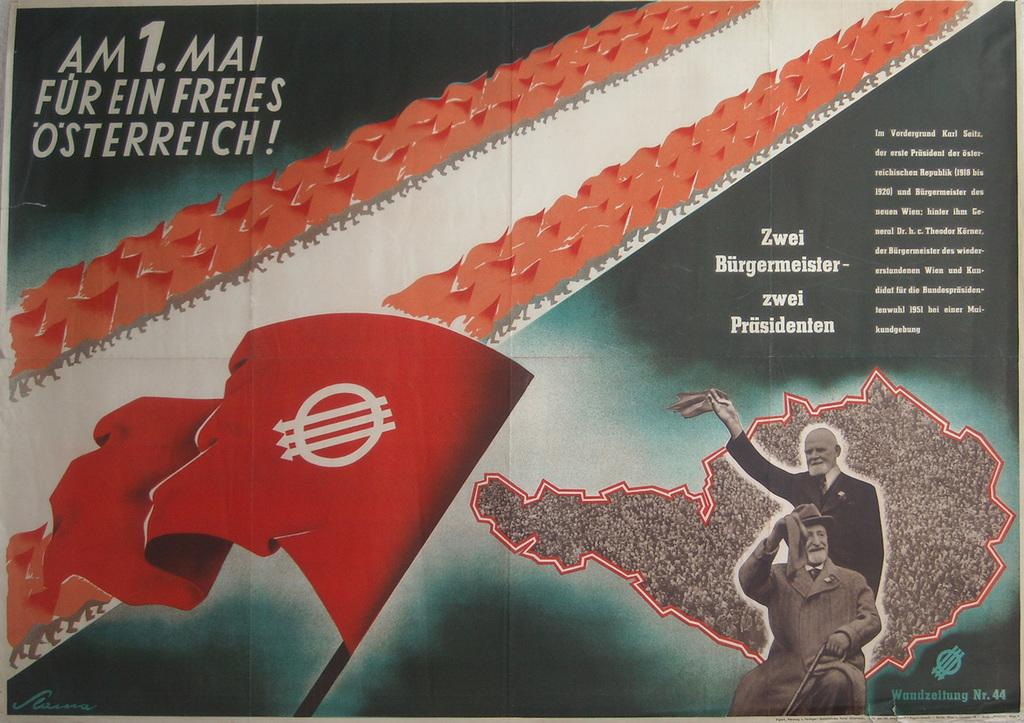Provide a one-sentence caption for the provided image. Poster showing two men and a flag and says "Am 1. Mai Fur Ein Freies Osterreich!". 